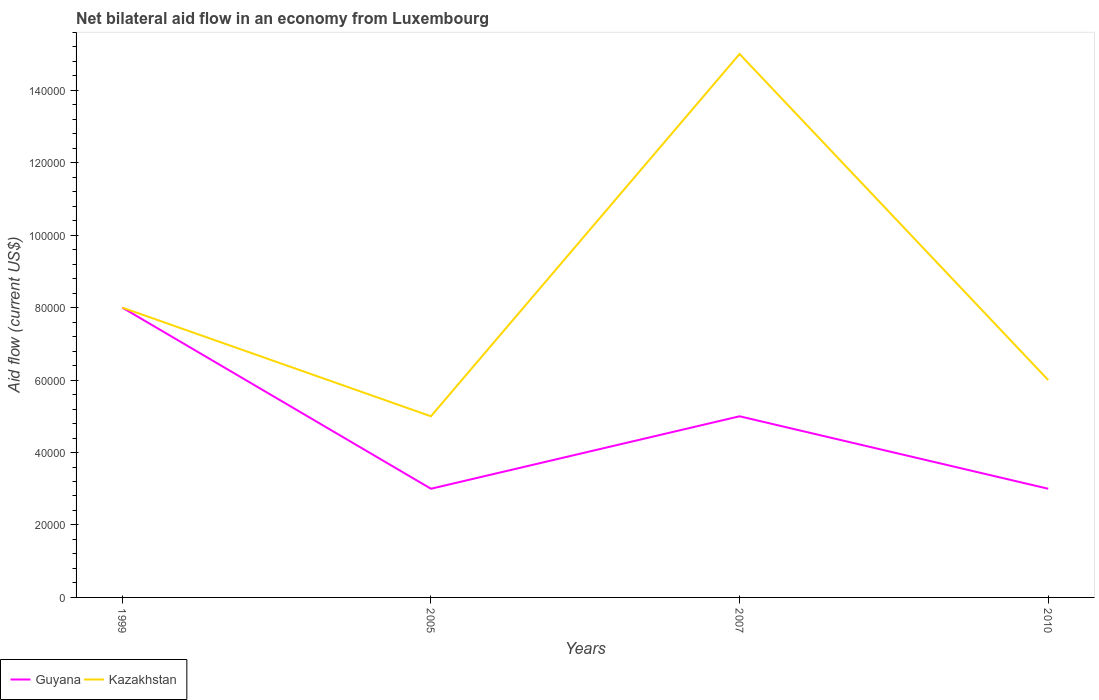How many different coloured lines are there?
Provide a short and direct response. 2. Does the line corresponding to Guyana intersect with the line corresponding to Kazakhstan?
Provide a succinct answer. Yes. Is the number of lines equal to the number of legend labels?
Ensure brevity in your answer.  Yes. Across all years, what is the maximum net bilateral aid flow in Guyana?
Your answer should be compact. 3.00e+04. In which year was the net bilateral aid flow in Kazakhstan maximum?
Provide a short and direct response. 2005. What is the total net bilateral aid flow in Guyana in the graph?
Your answer should be very brief. 3.00e+04. What is the difference between the highest and the lowest net bilateral aid flow in Guyana?
Keep it short and to the point. 2. How many lines are there?
Make the answer very short. 2. What is the difference between two consecutive major ticks on the Y-axis?
Keep it short and to the point. 2.00e+04. Are the values on the major ticks of Y-axis written in scientific E-notation?
Ensure brevity in your answer.  No. Does the graph contain any zero values?
Offer a very short reply. No. Where does the legend appear in the graph?
Your answer should be compact. Bottom left. How many legend labels are there?
Make the answer very short. 2. How are the legend labels stacked?
Offer a terse response. Horizontal. What is the title of the graph?
Provide a succinct answer. Net bilateral aid flow in an economy from Luxembourg. What is the Aid flow (current US$) in Kazakhstan in 1999?
Provide a short and direct response. 8.00e+04. What is the Aid flow (current US$) in Guyana in 2005?
Keep it short and to the point. 3.00e+04. What is the Aid flow (current US$) of Kazakhstan in 2005?
Your answer should be very brief. 5.00e+04. What is the Aid flow (current US$) in Guyana in 2007?
Ensure brevity in your answer.  5.00e+04. What is the Aid flow (current US$) in Kazakhstan in 2007?
Offer a very short reply. 1.50e+05. What is the Aid flow (current US$) in Kazakhstan in 2010?
Your answer should be compact. 6.00e+04. Across all years, what is the maximum Aid flow (current US$) of Guyana?
Your answer should be very brief. 8.00e+04. Across all years, what is the maximum Aid flow (current US$) of Kazakhstan?
Your response must be concise. 1.50e+05. Across all years, what is the minimum Aid flow (current US$) of Guyana?
Your response must be concise. 3.00e+04. Across all years, what is the minimum Aid flow (current US$) in Kazakhstan?
Ensure brevity in your answer.  5.00e+04. What is the difference between the Aid flow (current US$) in Guyana in 1999 and that in 2007?
Provide a short and direct response. 3.00e+04. What is the difference between the Aid flow (current US$) of Guyana in 1999 and that in 2010?
Keep it short and to the point. 5.00e+04. What is the difference between the Aid flow (current US$) of Kazakhstan in 2005 and that in 2007?
Ensure brevity in your answer.  -1.00e+05. What is the difference between the Aid flow (current US$) in Guyana in 1999 and the Aid flow (current US$) in Kazakhstan in 2007?
Make the answer very short. -7.00e+04. What is the difference between the Aid flow (current US$) of Guyana in 2007 and the Aid flow (current US$) of Kazakhstan in 2010?
Provide a succinct answer. -10000. What is the average Aid flow (current US$) in Guyana per year?
Give a very brief answer. 4.75e+04. What is the average Aid flow (current US$) of Kazakhstan per year?
Your answer should be very brief. 8.50e+04. In the year 1999, what is the difference between the Aid flow (current US$) in Guyana and Aid flow (current US$) in Kazakhstan?
Offer a terse response. 0. In the year 2007, what is the difference between the Aid flow (current US$) in Guyana and Aid flow (current US$) in Kazakhstan?
Your answer should be very brief. -1.00e+05. What is the ratio of the Aid flow (current US$) in Guyana in 1999 to that in 2005?
Keep it short and to the point. 2.67. What is the ratio of the Aid flow (current US$) of Kazakhstan in 1999 to that in 2005?
Your answer should be very brief. 1.6. What is the ratio of the Aid flow (current US$) of Guyana in 1999 to that in 2007?
Give a very brief answer. 1.6. What is the ratio of the Aid flow (current US$) of Kazakhstan in 1999 to that in 2007?
Provide a succinct answer. 0.53. What is the ratio of the Aid flow (current US$) in Guyana in 1999 to that in 2010?
Ensure brevity in your answer.  2.67. What is the ratio of the Aid flow (current US$) in Guyana in 2005 to that in 2010?
Make the answer very short. 1. What is the ratio of the Aid flow (current US$) of Guyana in 2007 to that in 2010?
Your response must be concise. 1.67. What is the ratio of the Aid flow (current US$) of Kazakhstan in 2007 to that in 2010?
Keep it short and to the point. 2.5. What is the difference between the highest and the second highest Aid flow (current US$) of Kazakhstan?
Your answer should be compact. 7.00e+04. 